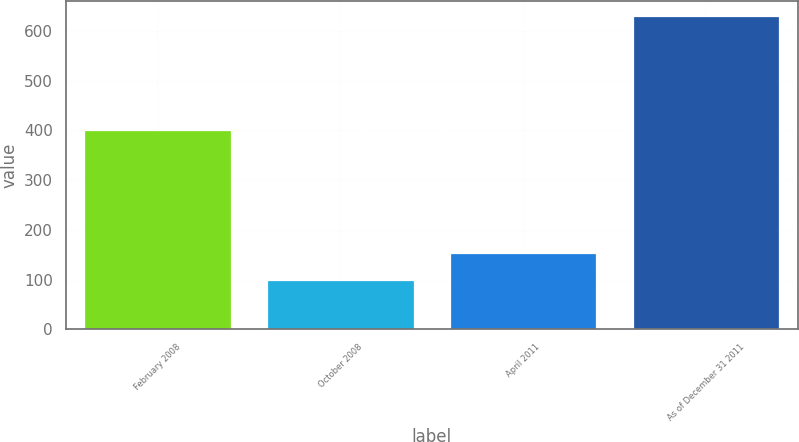Convert chart. <chart><loc_0><loc_0><loc_500><loc_500><bar_chart><fcel>February 2008<fcel>October 2008<fcel>April 2011<fcel>As of December 31 2011<nl><fcel>400<fcel>100<fcel>152.9<fcel>629<nl></chart> 